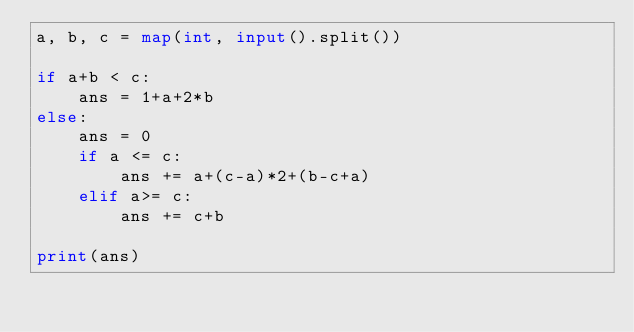<code> <loc_0><loc_0><loc_500><loc_500><_Python_>a, b, c = map(int, input().split())

if a+b < c:
    ans = 1+a+2*b
else:
    ans = 0
    if a <= c:
        ans += a+(c-a)*2+(b-c+a)
    elif a>= c:
        ans += c+b
    
print(ans)</code> 